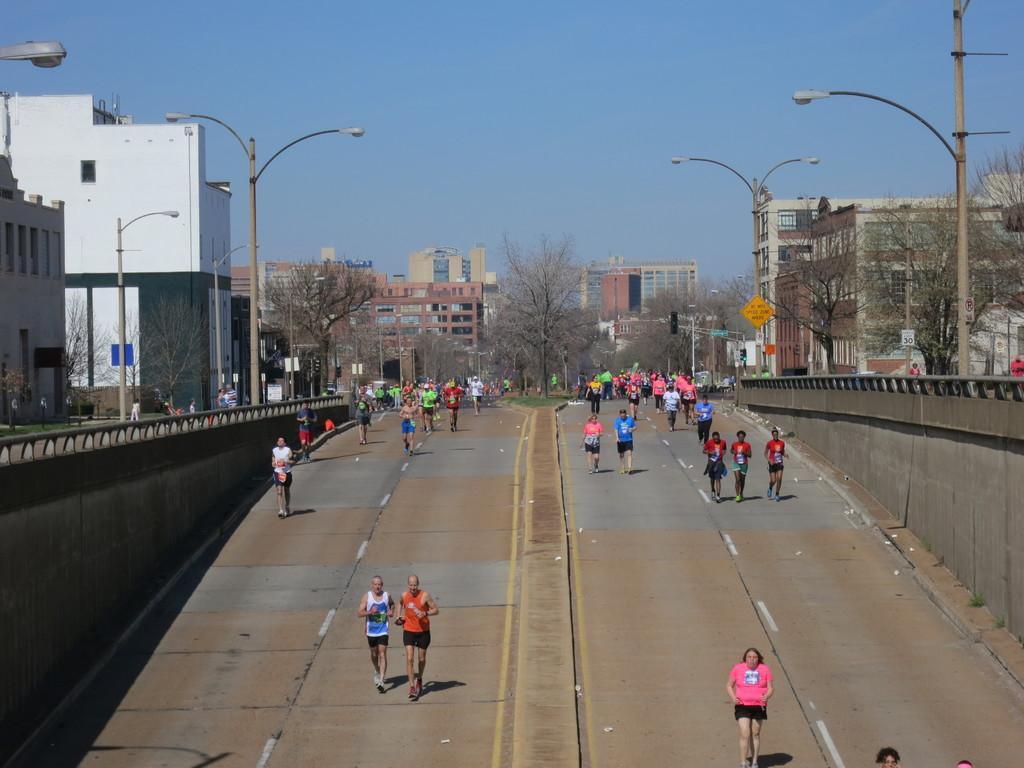Describe this image in one or two sentences. In this picture I can see so many people are walking on the roadside there are some trees and buildings. 